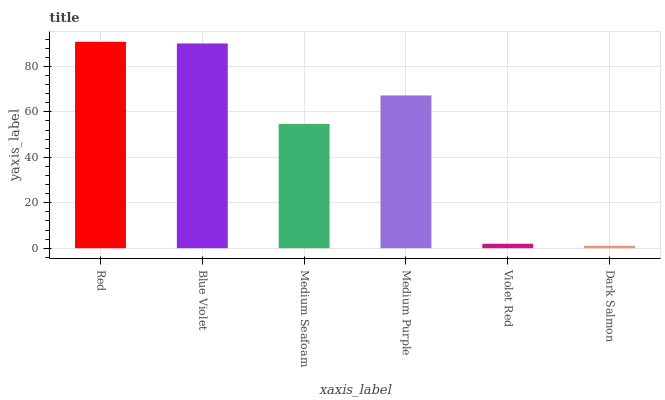Is Blue Violet the minimum?
Answer yes or no. No. Is Blue Violet the maximum?
Answer yes or no. No. Is Red greater than Blue Violet?
Answer yes or no. Yes. Is Blue Violet less than Red?
Answer yes or no. Yes. Is Blue Violet greater than Red?
Answer yes or no. No. Is Red less than Blue Violet?
Answer yes or no. No. Is Medium Purple the high median?
Answer yes or no. Yes. Is Medium Seafoam the low median?
Answer yes or no. Yes. Is Dark Salmon the high median?
Answer yes or no. No. Is Medium Purple the low median?
Answer yes or no. No. 